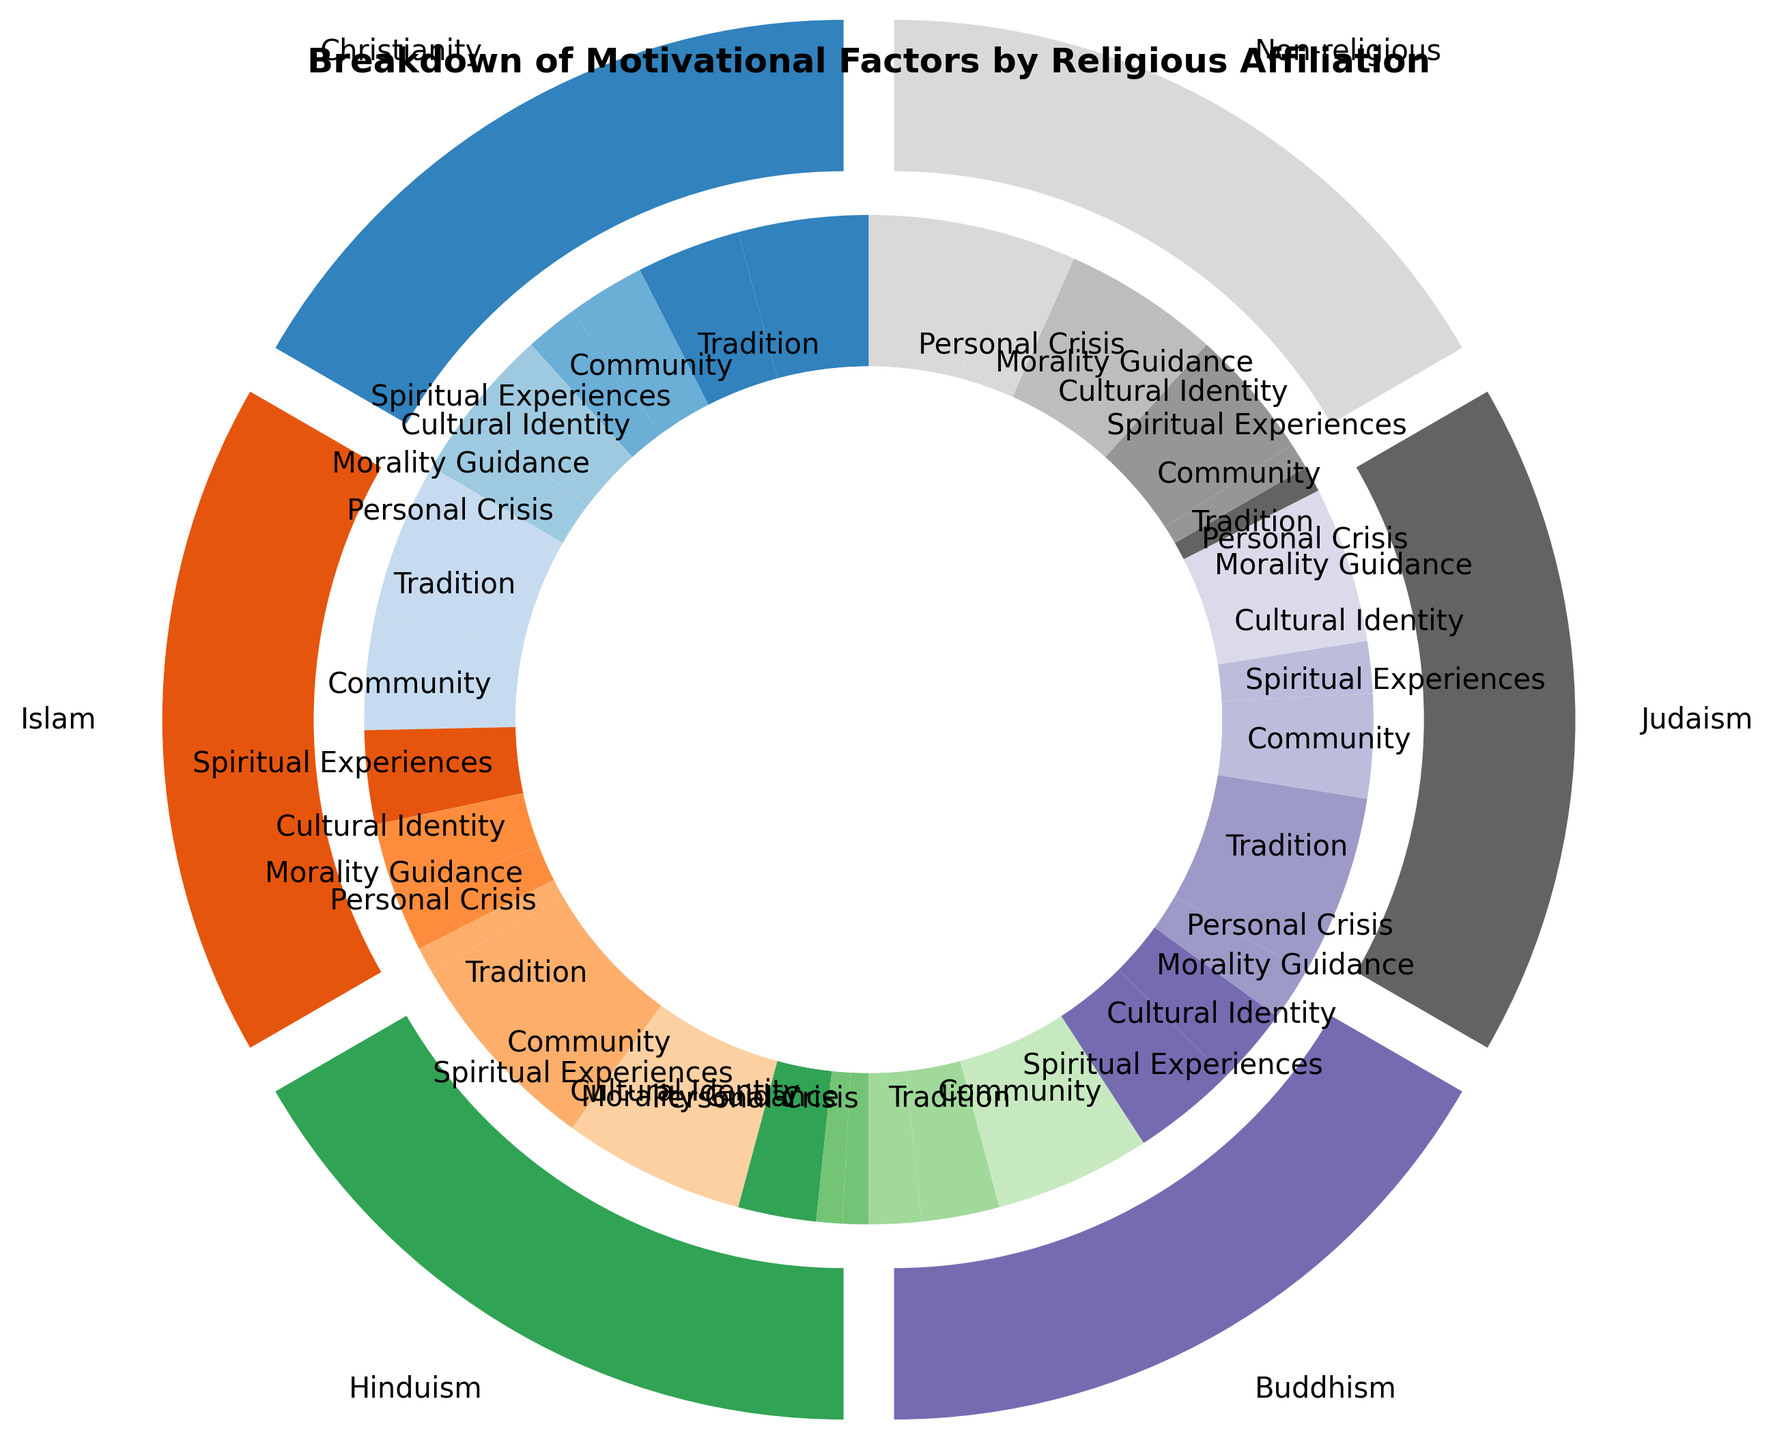What percentage of Christianity adherents cite Tradition as a motivational factor? Locate the outer wedge labeled "Christianity," then find the inner wedge corresponding to "Tradition." The percentage labeled is 25%.
Answer: 25% Which religious affiliation has the highest percentage for the motivational factor of Community? Compare the Community percentages across all religious affiliations. The highest percentage for Community is found in the Non-religious group, at 25%.
Answer: Non-religious How does the percentage for Tradition in Judaism compare to that in Buddhism? Locate the wedges for Tradition in both Judaism and Buddhism. Judaism has 35%, while Buddhism has 10%. Thus, Judaism’s percentage for Tradition is greater.
Answer: Judaism's percentage for Tradition is greater What is the combined percentage for Spiritual Experiences in Islam and Buddhism? Find the percentages for Spiritual Experiences in Islam (18%) and Buddhism (30%). Sum these percentages: 18% + 30% = 48%.
Answer: 48% How does the motivational factor of Personal Crisis for Non-religious compare to Personal Crisis for Christianity? Locate the wedges for Personal Crisis in both Non-religious (25%) and Christianity (12%). Non-religious has a higher percentage for Personal Crisis than Christianity.
Answer: Non-religious has a higher percentage Which motivational factor in Hinduism has the lowest percentage? Identify all motivational factors in Hinduism and their percentages. The lowest percentages are for Morality Guidance and Personal Crisis, both at 5%.
Answer: Morality Guidance and Personal Crisis What is the difference in the percentage citing Cultural Identity between Islam and Judaism? Find the Cultural Identity percentages for Islam (15%) and Judaism (20%). The difference is 20% - 15% = 5%.
Answer: 5% How much more likely are adherents of Christianity to cite Tradition as a motivational factor compared to Spiritual Experiences? Identify the percentages for Tradition (25%) and Spiritual Experiences (15%) in Christianity. The difference is 25% - 15% = 10%.
Answer: 10% What is the sum of the percentages for all motivational factors in Buddhism? Add the percentages for all factors in Buddhism: 10% (Tradition) + 15% (Community) + 30% (Spiritual Experiences) + 20% (Cultural Identity) + 15% (Morality Guidance) + 10% (Personal Crisis) = 100%.
Answer: 100% Which religious affiliation has the least percentage attributed to Personal Crisis, and what is that percentage? Compare the Personal Crisis percentages across all affiliations. The lowest is in Islam at 5%.
Answer: Islam, 5% 